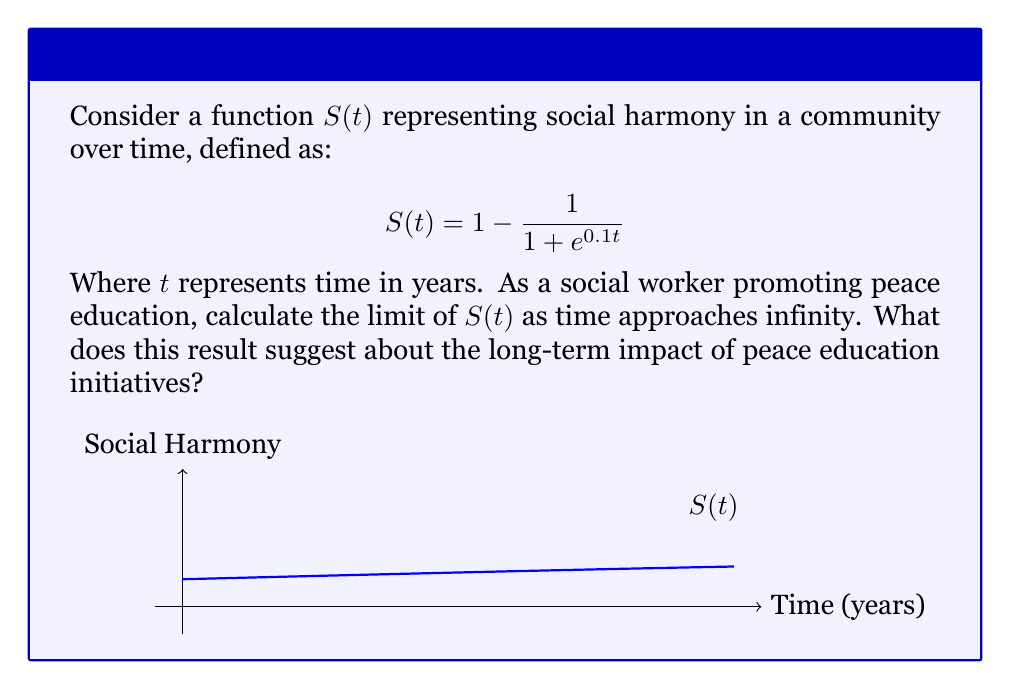Teach me how to tackle this problem. Let's approach this step-by-step:

1) We need to calculate $\lim_{t \to \infty} S(t)$

2) Substituting the given function:
   
   $$\lim_{t \to \infty} S(t) = \lim_{t \to \infty} \left(1 - \frac{1}{1 + e^{0.1t}}\right)$$

3) As $t$ approaches infinity, $e^{0.1t}$ will grow exponentially large:
   
   $$\lim_{t \to \infty} e^{0.1t} = \infty$$

4) Therefore, as $t$ approaches infinity:
   
   $$\lim_{t \to \infty} (1 + e^{0.1t}) = \infty$$

5) Now, let's consider the fraction $\frac{1}{1 + e^{0.1t}}$:
   
   $$\lim_{t \to \infty} \frac{1}{1 + e^{0.1t}} = \frac{1}{\infty} = 0$$

6) Returning to our original function:
   
   $$\lim_{t \to \infty} S(t) = \lim_{t \to \infty} \left(1 - \frac{1}{1 + e^{0.1t}}\right) = 1 - 0 = 1$$

7) Interpretation: This result suggests that as time approaches infinity, the social harmony function approaches 1, indicating that peace education initiatives can lead to a state of maximum social harmony in the long term.
Answer: $\lim_{t \to \infty} S(t) = 1$ 